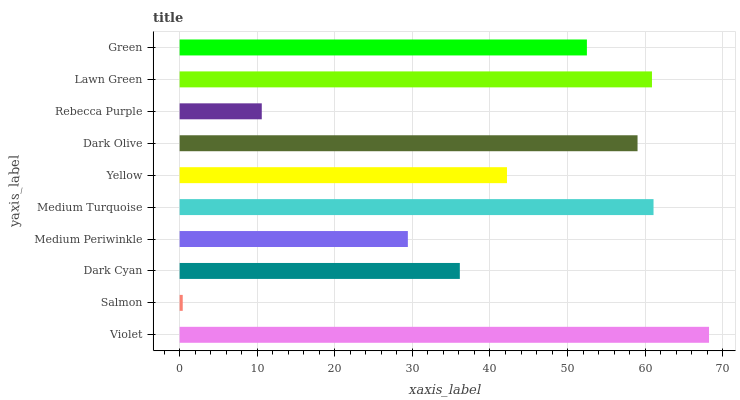Is Salmon the minimum?
Answer yes or no. Yes. Is Violet the maximum?
Answer yes or no. Yes. Is Dark Cyan the minimum?
Answer yes or no. No. Is Dark Cyan the maximum?
Answer yes or no. No. Is Dark Cyan greater than Salmon?
Answer yes or no. Yes. Is Salmon less than Dark Cyan?
Answer yes or no. Yes. Is Salmon greater than Dark Cyan?
Answer yes or no. No. Is Dark Cyan less than Salmon?
Answer yes or no. No. Is Green the high median?
Answer yes or no. Yes. Is Yellow the low median?
Answer yes or no. Yes. Is Yellow the high median?
Answer yes or no. No. Is Lawn Green the low median?
Answer yes or no. No. 